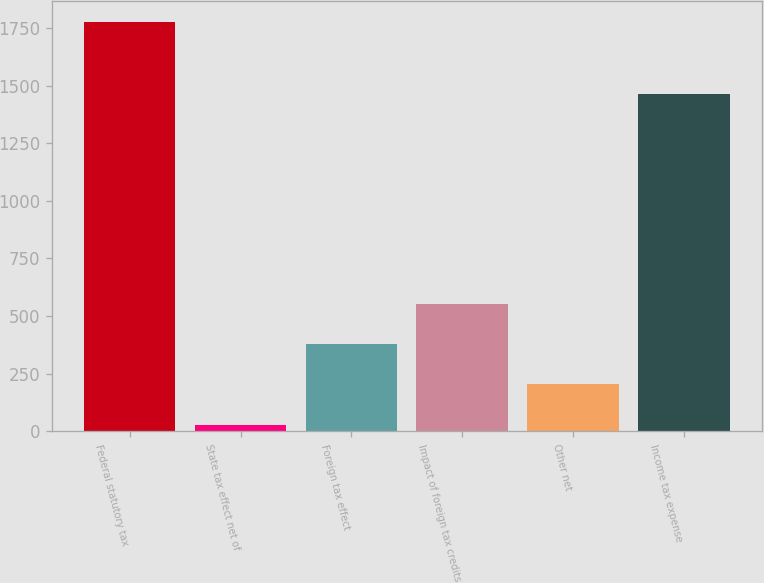<chart> <loc_0><loc_0><loc_500><loc_500><bar_chart><fcel>Federal statutory tax<fcel>State tax effect net of<fcel>Foreign tax effect<fcel>Impact of foreign tax credits<fcel>Other net<fcel>Income tax expense<nl><fcel>1778<fcel>29<fcel>378.8<fcel>553.7<fcel>203.9<fcel>1462<nl></chart> 